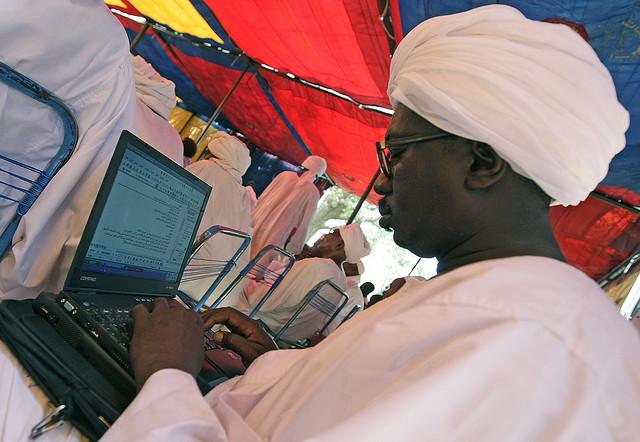What is the man wearing on his head?
Give a very brief answer. Turban. Does the man has blonde hair?
Short answer required. No. Is this computer high tech?
Write a very short answer. Yes. 